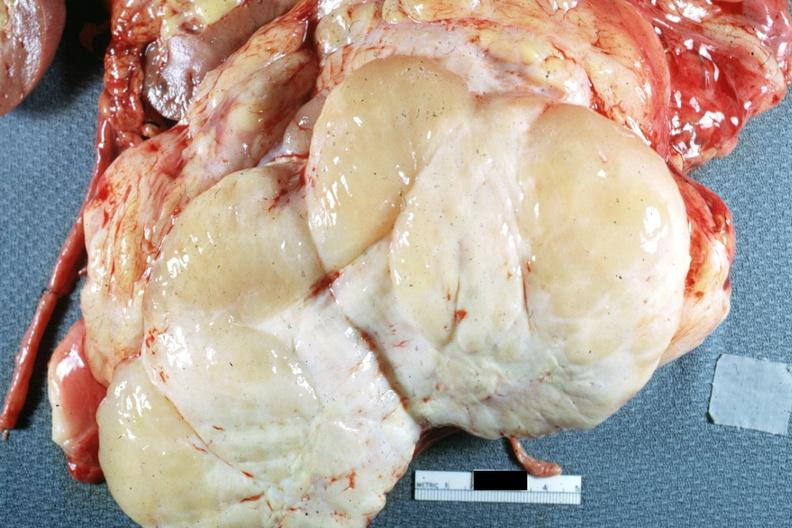what is present?
Answer the question using a single word or phrase. Retroperitoneal liposarcoma 